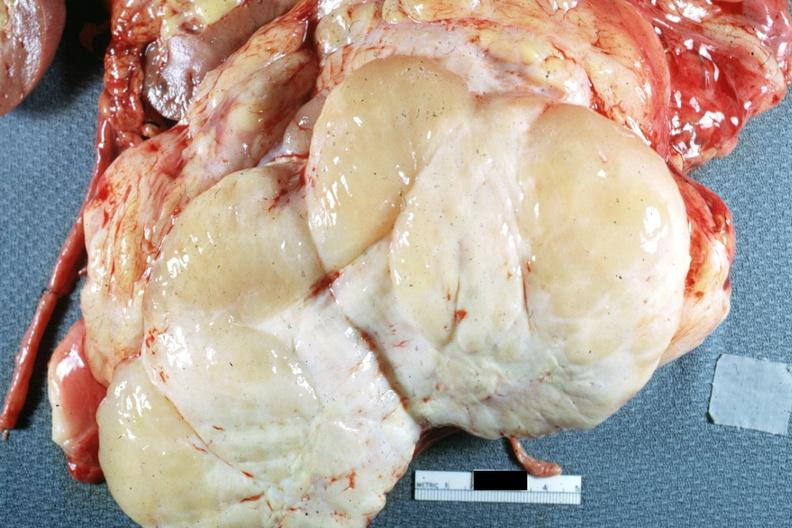what is present?
Answer the question using a single word or phrase. Retroperitoneal liposarcoma 